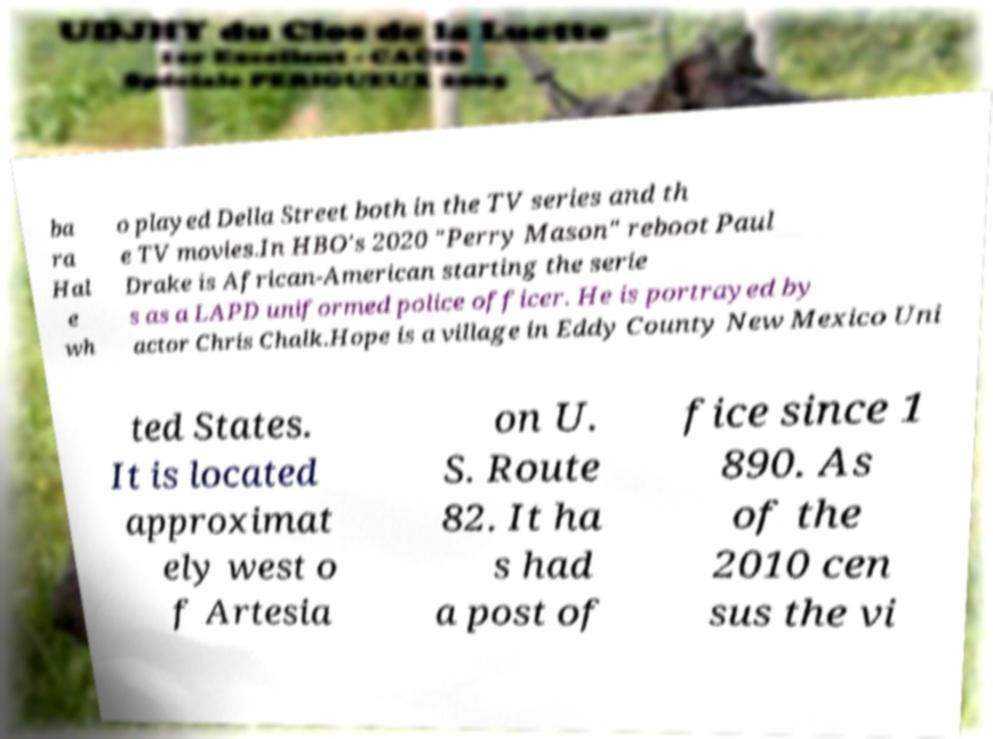Please identify and transcribe the text found in this image. ba ra Hal e wh o played Della Street both in the TV series and th e TV movies.In HBO's 2020 "Perry Mason" reboot Paul Drake is African-American starting the serie s as a LAPD uniformed police officer. He is portrayed by actor Chris Chalk.Hope is a village in Eddy County New Mexico Uni ted States. It is located approximat ely west o f Artesia on U. S. Route 82. It ha s had a post of fice since 1 890. As of the 2010 cen sus the vi 